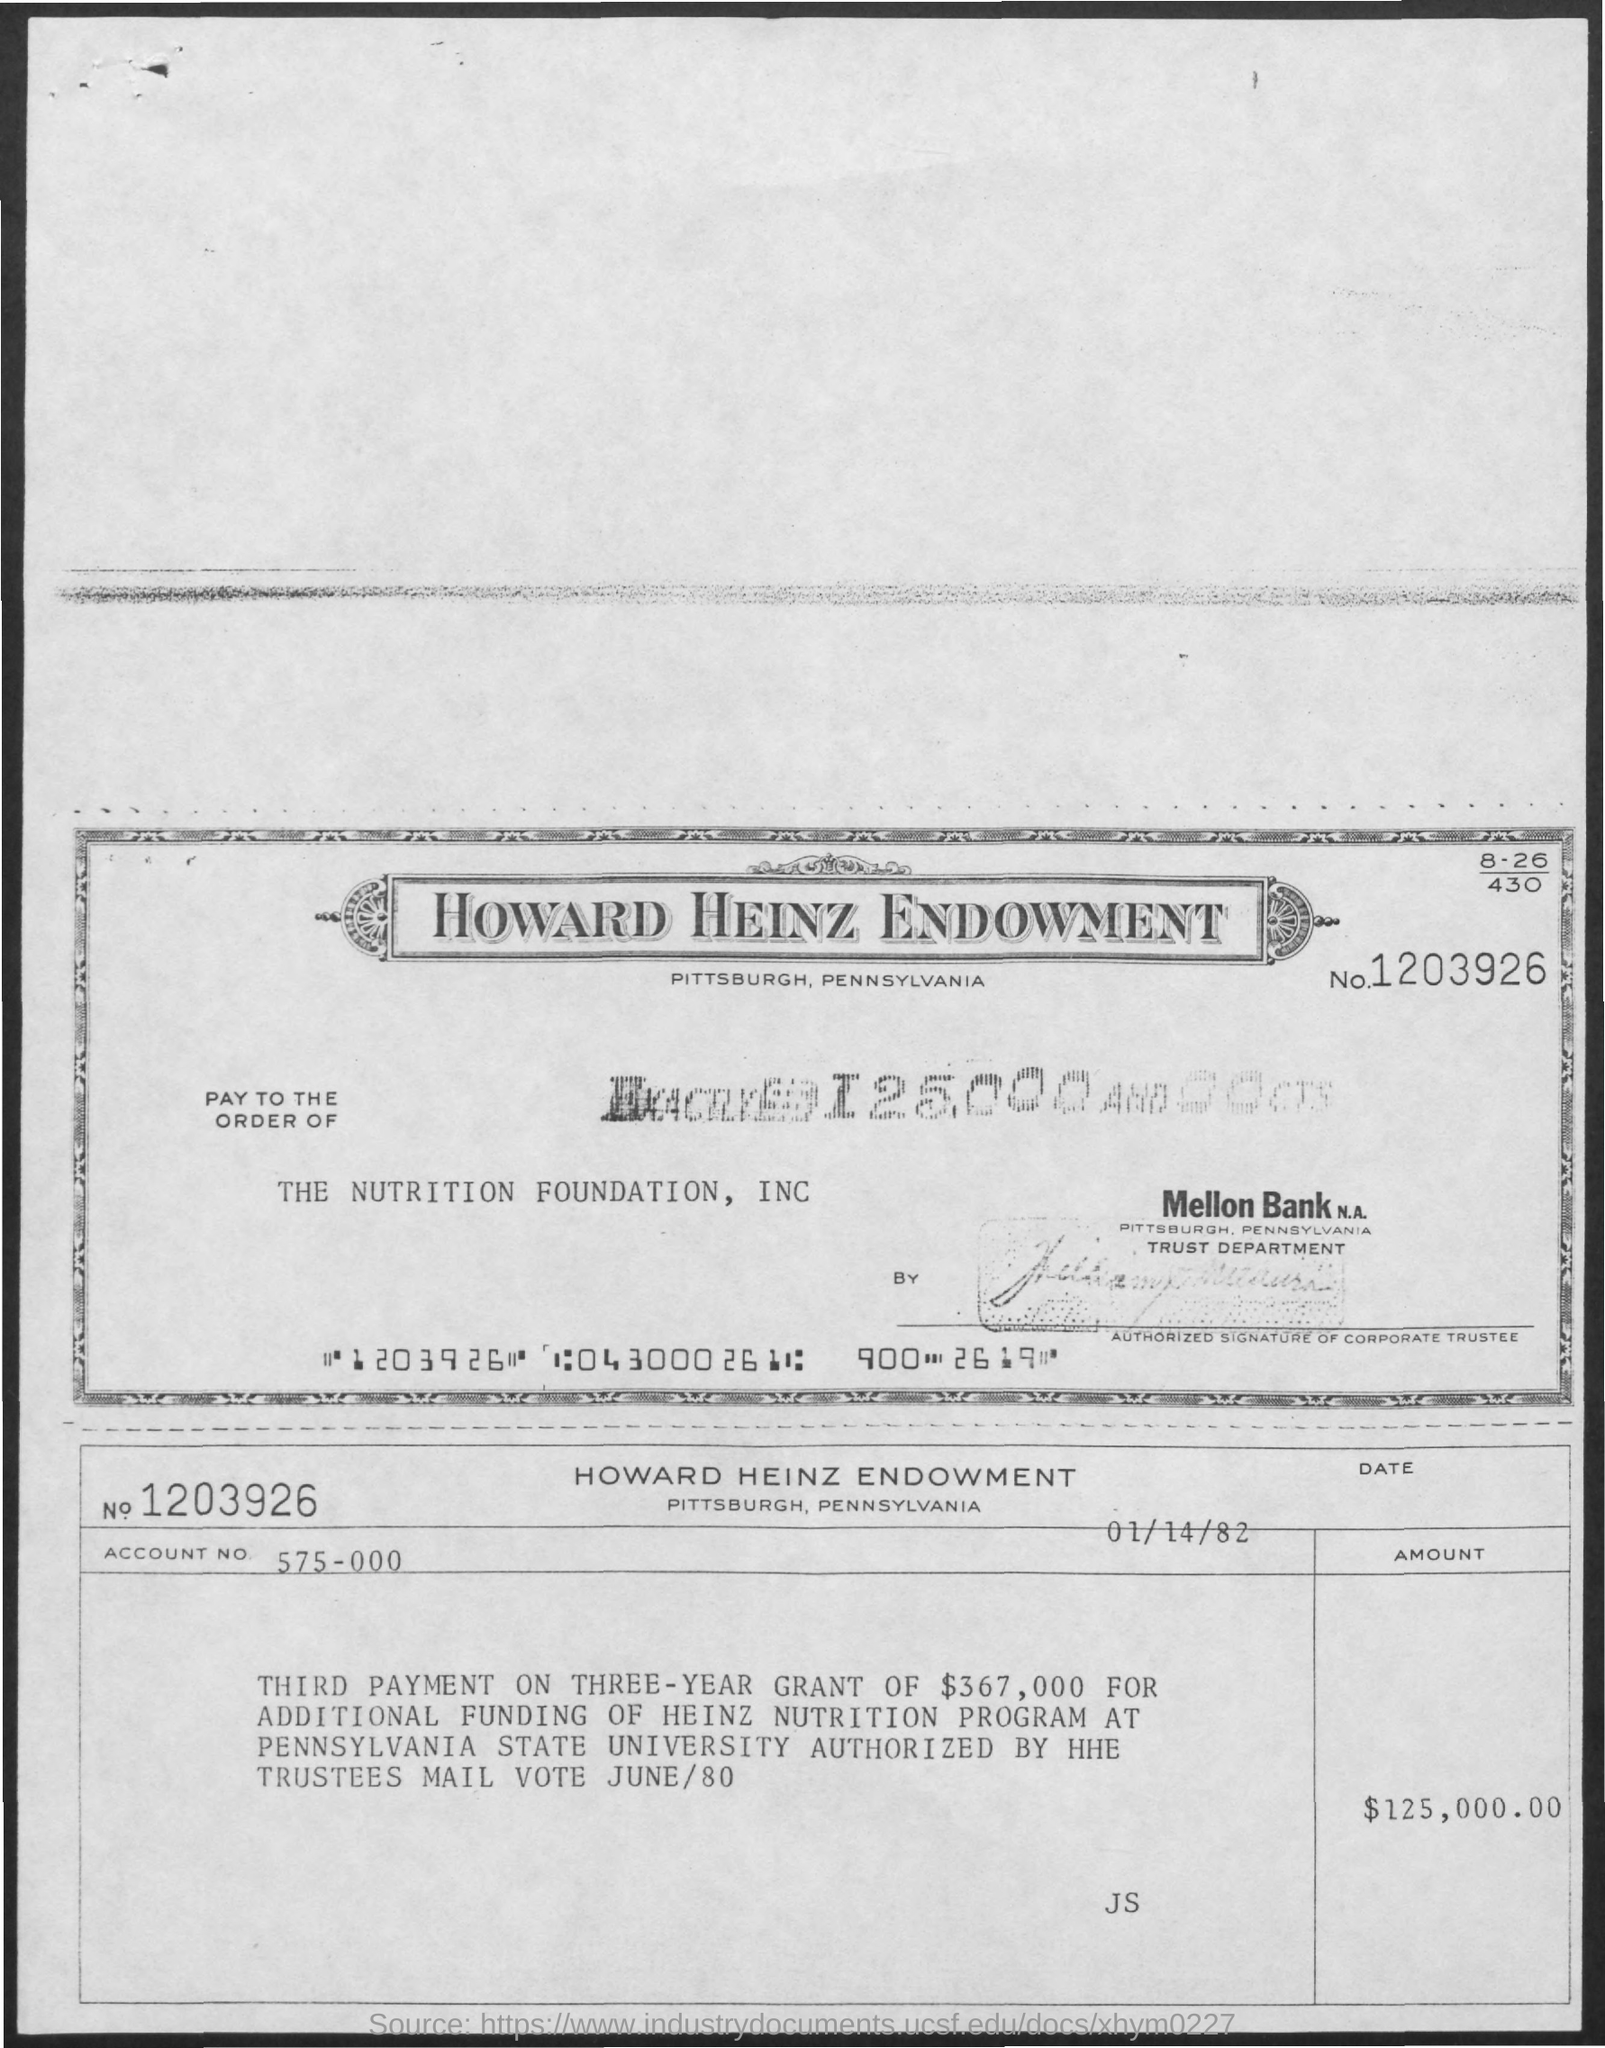What is the account no. mentioned ?
Ensure brevity in your answer.  575-000. What is the date mentioned in the given page ?
Ensure brevity in your answer.  01/14/82. What is the no. mentioned in the given form ?
Give a very brief answer. 1203926. What is the name mentioned at pay to the order of ?
Offer a very short reply. THE NUTRITION FOUNDATION INC. What is the amount mentioned in the given form ?
Your answer should be very brief. $125,000AND00CTS. 